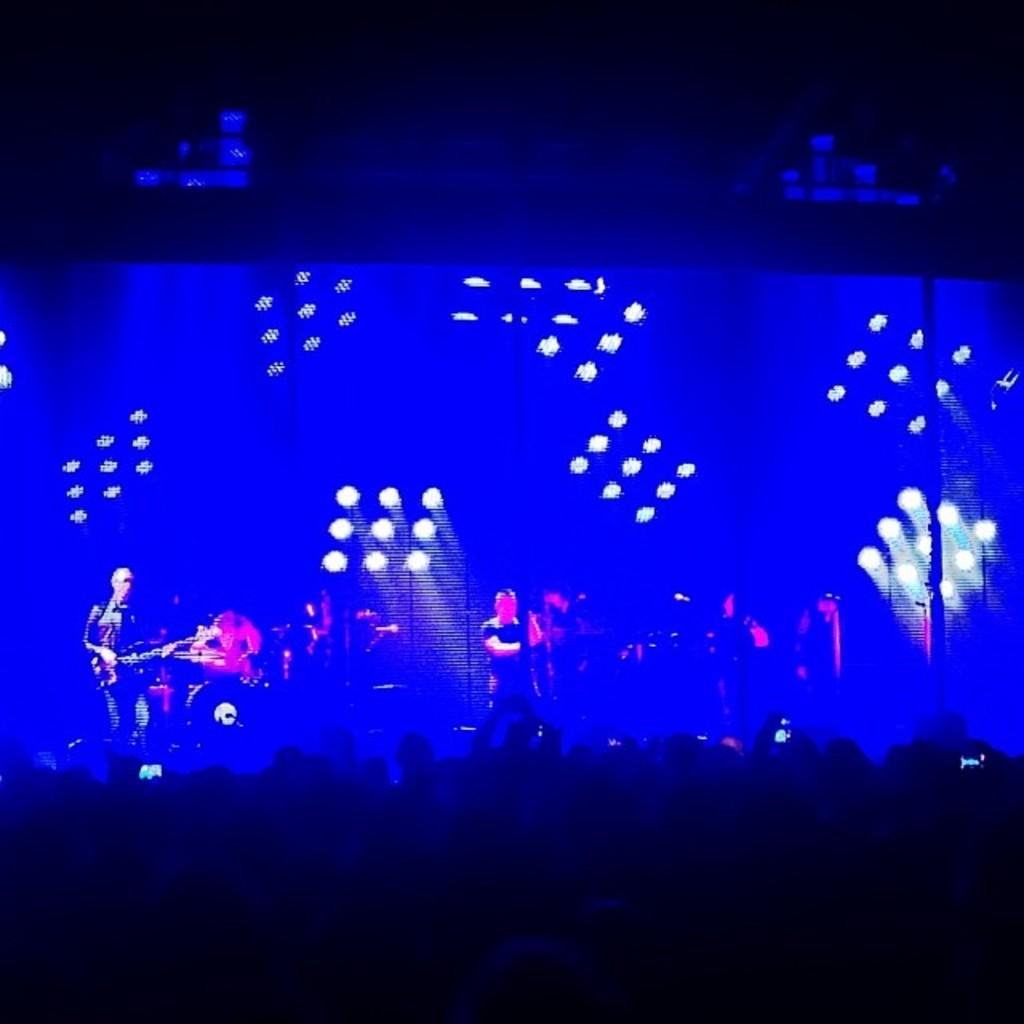What are the people in the image wearing? The people in the image are wearing clothes. What type of lighting is present in the image? Disco lights are present in the image. What objects can be seen that are typically used for making music? Musical instruments are visible in the image. How would you describe the lighting in the image? The top and bottom of the image are dark. Can you tell me how many toothbrushes are being used in the image? There are no toothbrushes present in the image. What type of rule is being enforced in the image? There is no rule being enforced in the image; it features people, disco lights, and musical instruments. 